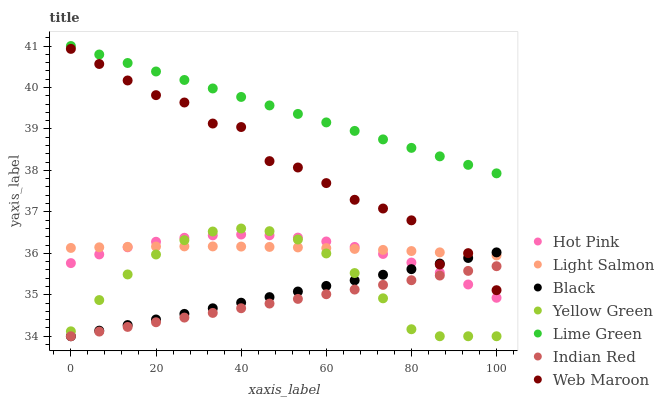Does Indian Red have the minimum area under the curve?
Answer yes or no. Yes. Does Lime Green have the maximum area under the curve?
Answer yes or no. Yes. Does Yellow Green have the minimum area under the curve?
Answer yes or no. No. Does Yellow Green have the maximum area under the curve?
Answer yes or no. No. Is Lime Green the smoothest?
Answer yes or no. Yes. Is Web Maroon the roughest?
Answer yes or no. Yes. Is Yellow Green the smoothest?
Answer yes or no. No. Is Yellow Green the roughest?
Answer yes or no. No. Does Yellow Green have the lowest value?
Answer yes or no. Yes. Does Hot Pink have the lowest value?
Answer yes or no. No. Does Lime Green have the highest value?
Answer yes or no. Yes. Does Yellow Green have the highest value?
Answer yes or no. No. Is Indian Red less than Lime Green?
Answer yes or no. Yes. Is Lime Green greater than Hot Pink?
Answer yes or no. Yes. Does Hot Pink intersect Light Salmon?
Answer yes or no. Yes. Is Hot Pink less than Light Salmon?
Answer yes or no. No. Is Hot Pink greater than Light Salmon?
Answer yes or no. No. Does Indian Red intersect Lime Green?
Answer yes or no. No. 